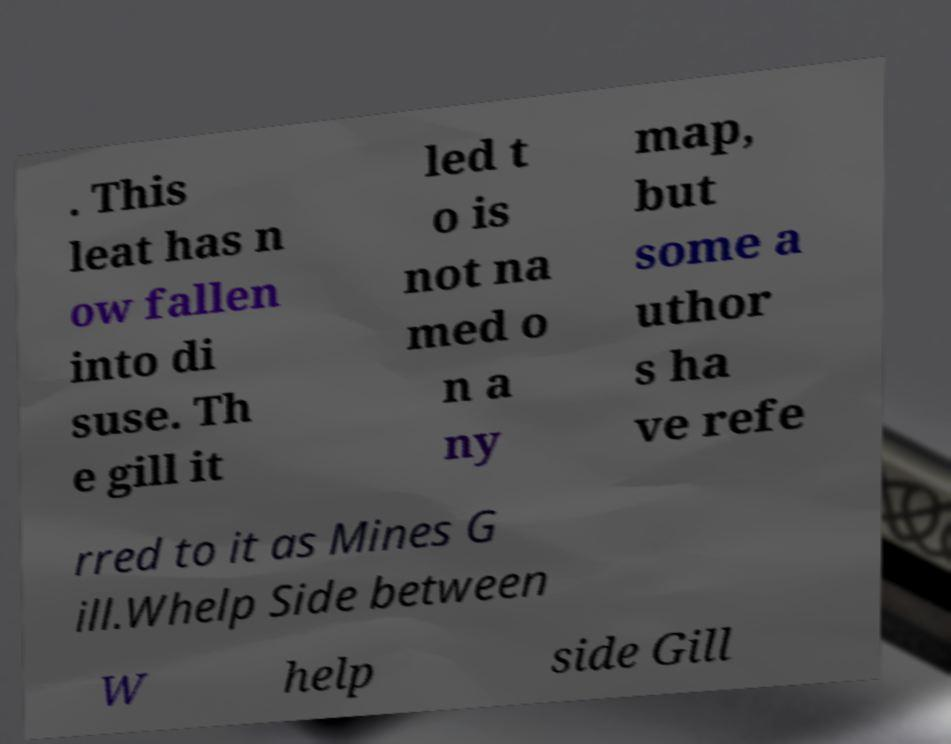What messages or text are displayed in this image? I need them in a readable, typed format. . This leat has n ow fallen into di suse. Th e gill it led t o is not na med o n a ny map, but some a uthor s ha ve refe rred to it as Mines G ill.Whelp Side between W help side Gill 